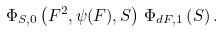Convert formula to latex. <formula><loc_0><loc_0><loc_500><loc_500>\Phi _ { S , 0 } \left ( F ^ { 2 } , \psi ( F ) , S \right ) \, \Phi _ { d F , 1 } \left ( S \right ) .</formula> 